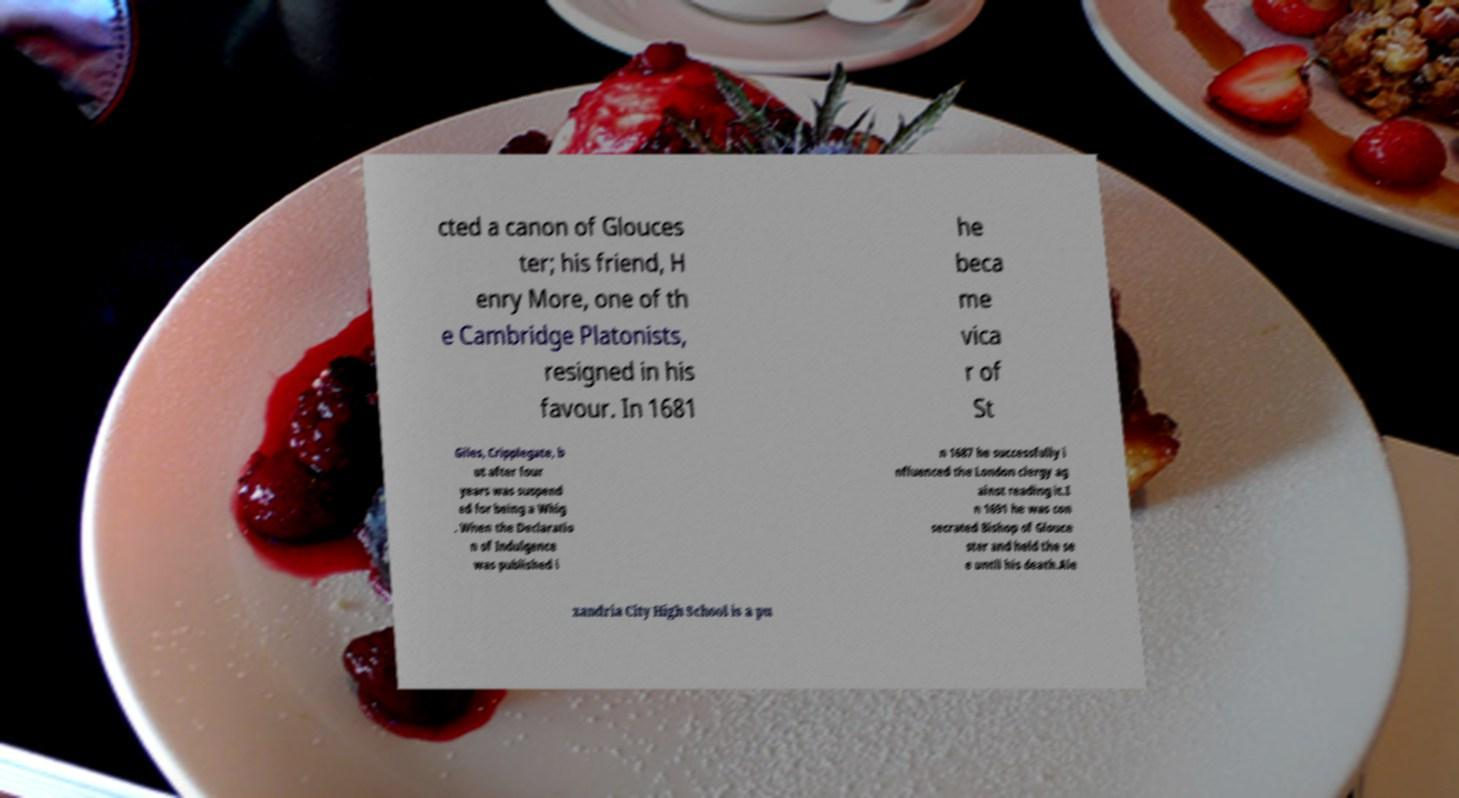Can you accurately transcribe the text from the provided image for me? cted a canon of Glouces ter; his friend, H enry More, one of th e Cambridge Platonists, resigned in his favour. In 1681 he beca me vica r of St Giles, Cripplegate, b ut after four years was suspend ed for being a Whig . When the Declaratio n of Indulgence was published i n 1687 he successfully i nfluenced the London clergy ag ainst reading it.I n 1691 he was con secrated Bishop of Glouce ster and held the se e until his death.Ale xandria City High School is a pu 